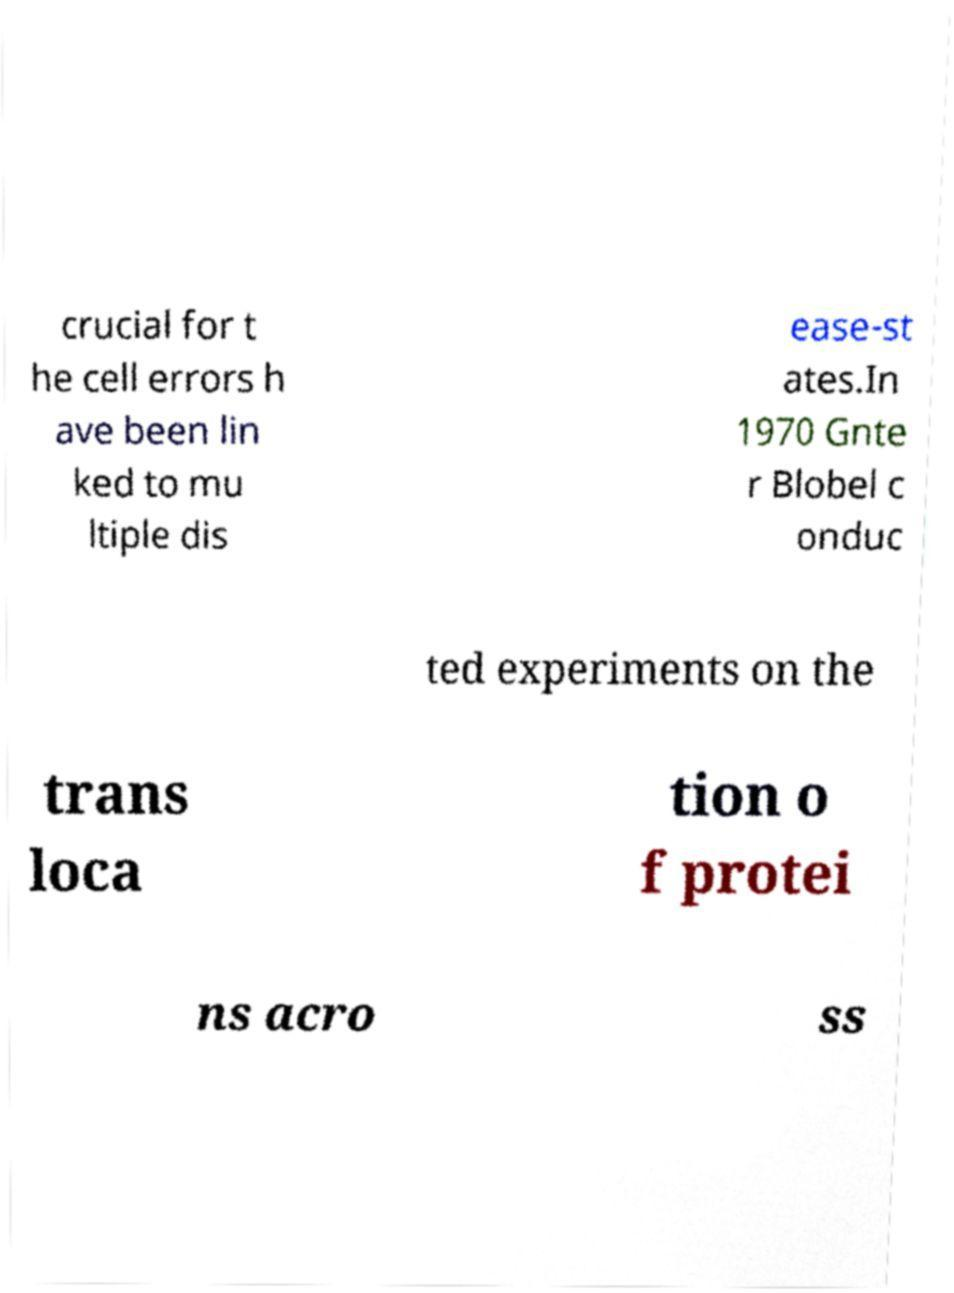For documentation purposes, I need the text within this image transcribed. Could you provide that? crucial for t he cell errors h ave been lin ked to mu ltiple dis ease-st ates.In 1970 Gnte r Blobel c onduc ted experiments on the trans loca tion o f protei ns acro ss 